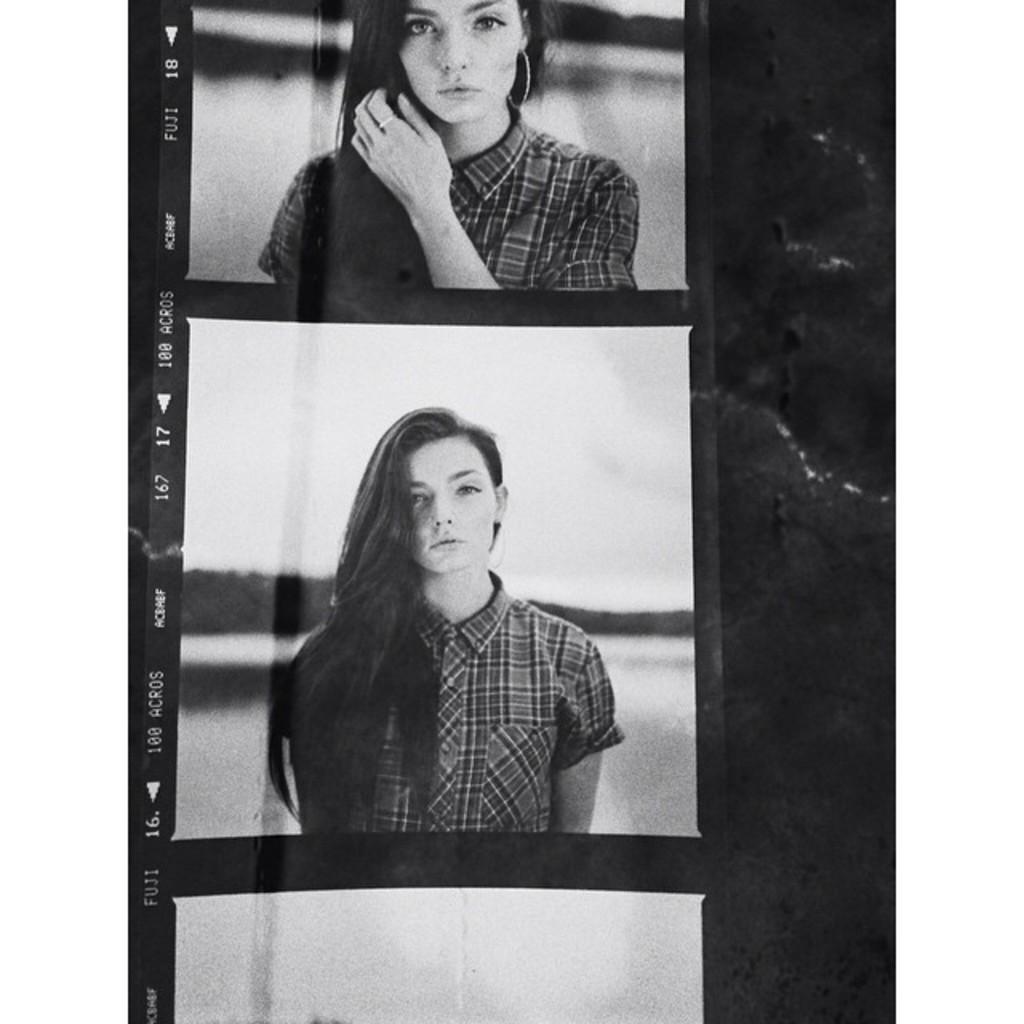Describe this image in one or two sentences. In this image we can see the photographs of a person, also we can see text on the photograph, and the borders are white in color. 